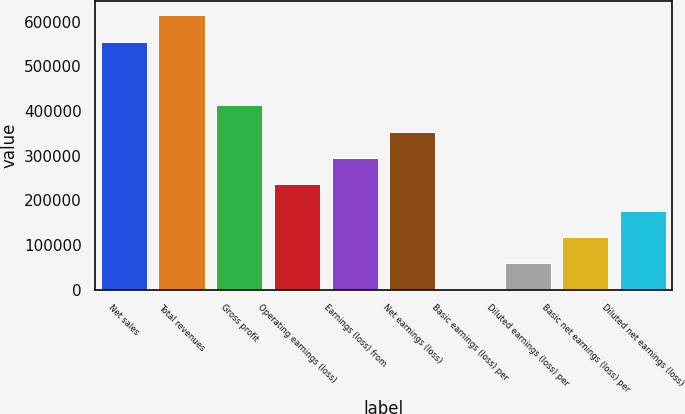Convert chart to OTSL. <chart><loc_0><loc_0><loc_500><loc_500><bar_chart><fcel>Net sales<fcel>Total revenues<fcel>Gross profit<fcel>Operating earnings (loss)<fcel>Earnings (loss) from<fcel>Net earnings (loss)<fcel>Basic earnings (loss) per<fcel>Diluted earnings (loss) per<fcel>Basic net earnings (loss) per<fcel>Diluted net earnings (loss)<nl><fcel>555768<fcel>614782<fcel>413102<fcel>236058<fcel>295073<fcel>354087<fcel>0.1<fcel>59014.6<fcel>118029<fcel>177044<nl></chart> 